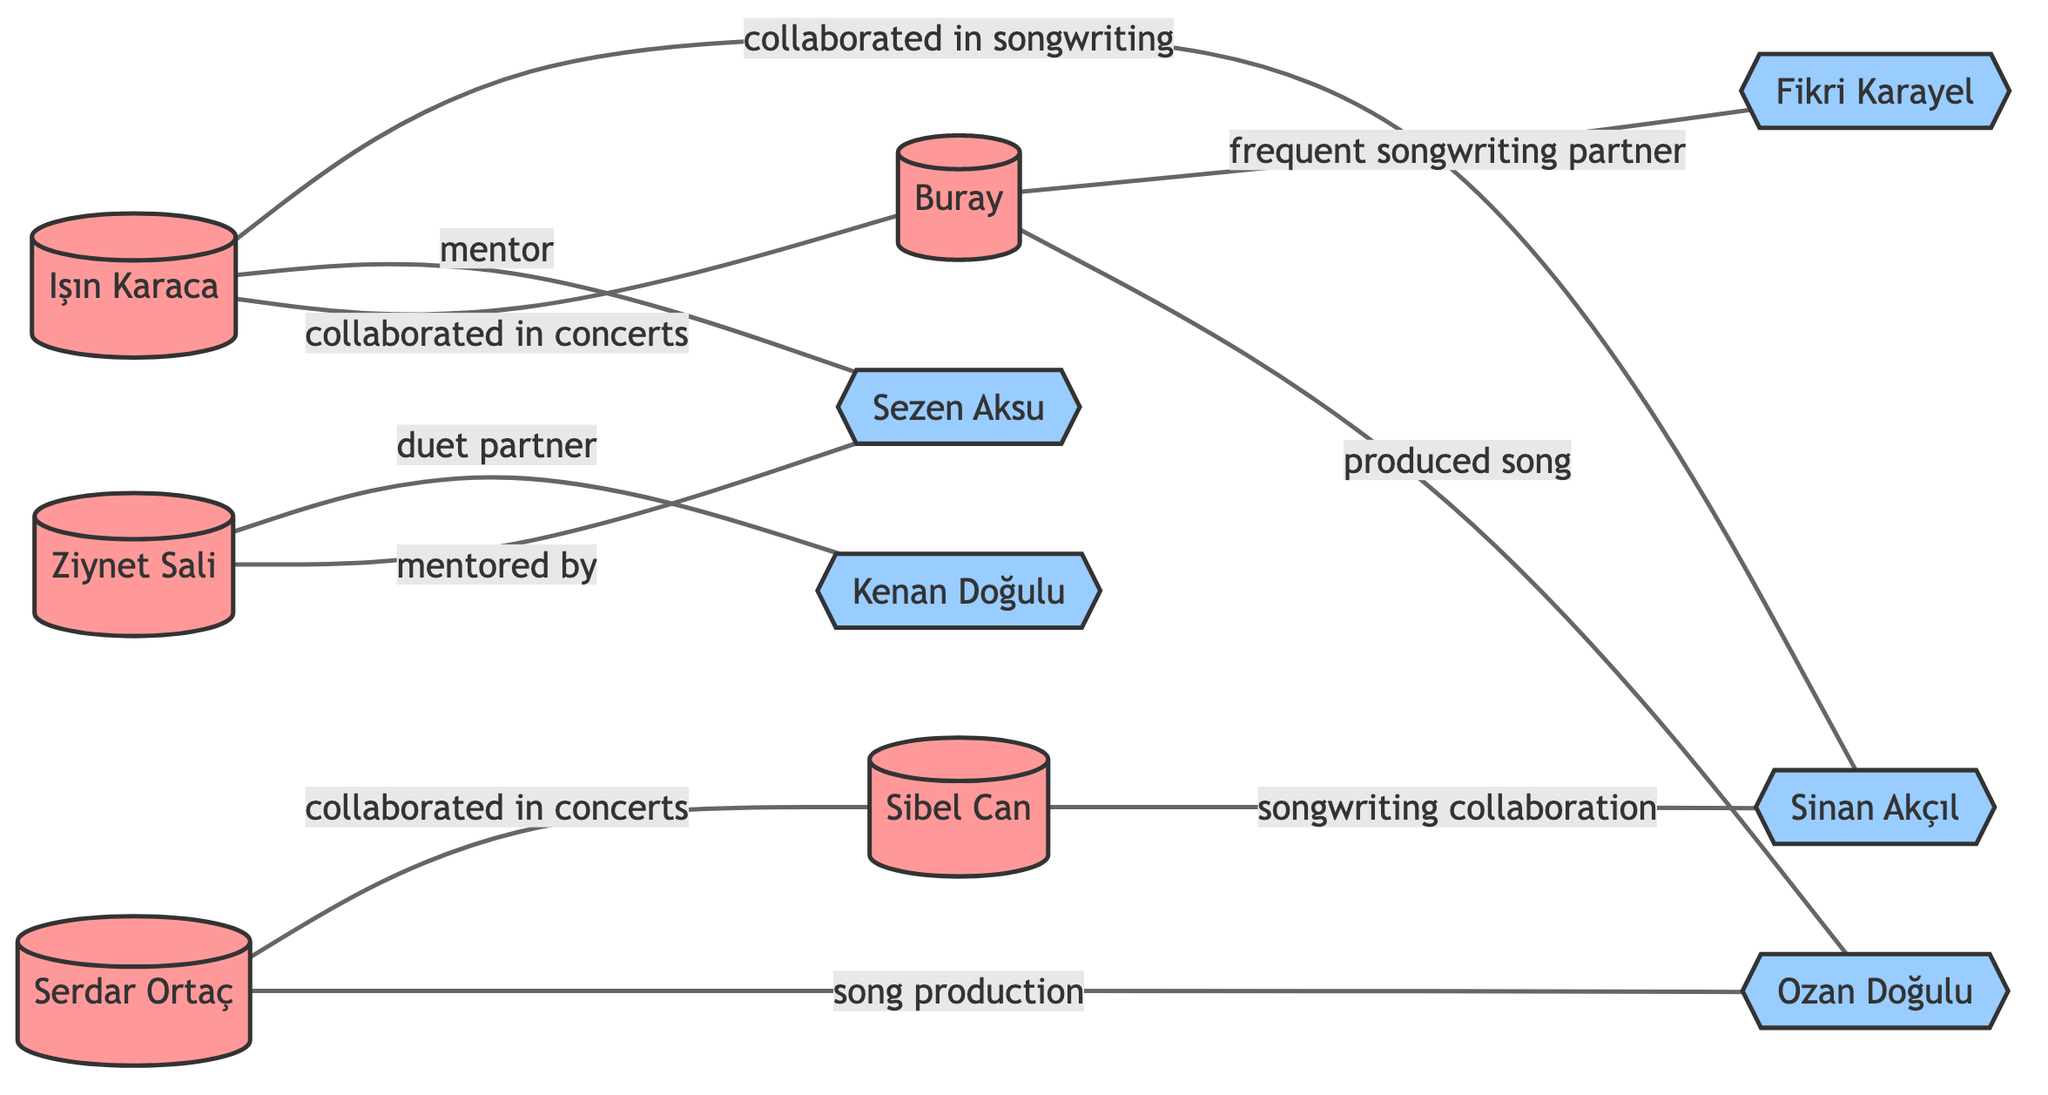What is the total number of artists in the diagram? The diagram lists five distinct nodes categorized as artists: Işın Karaca, Buray, Ziynet Sali, Serdar Ortaç, and Sibel Can. Therefore, counting these nodes gives a total of 5 artists.
Answer: 5 Who collaborated with Işın Karaca in songwriting? In the diagram, Işın Karaca is connected to Sinan Akçıl with the label "collaborated in songwriting," indicating that Sinan Akçıl collaborated with Işın Karaca in that capacity.
Answer: Sinan Akçıl Which artist is mentored by Sezen Aksu? The diagram shows an edge from Ziynet Sali to Sezen Aksu with the label "mentored by," confirming that Ziynet Sali is the artist mentored by Sezen Aksu.
Answer: Ziynet Sali How many total collaborations are listed in the diagram? By counting the edges connecting the nodes, the total number of collaborations is 9, as there are 9 labeled relationships indicating various forms of collaboration between the nodes.
Answer: 9 Which artists collaborated in concerts? Both Işın Karaca and Serdar Ortaç collaborated in concerts with the other artists as indicated by edges connecting them to Buray and Sibel Can respectively. Therefore, the answer includes Işın Karaca and Serdar Ortaç.
Answer: Işın Karaca, Serdar Ortaç What type of relationship exists between Buray and Ozan Doğulu? Based on the diagram, Buray has a relationship with Ozan Doğulu indicated by the edge labeled "produced song," which explicitly describes the nature of their collaboration.
Answer: produced song Who has the highest number of mentorship connections in the diagram? Examining the edges, Sezen Aksu is connected to two artists (Işın Karaca and Ziynet Sali), where both connections are labeled as mentorship. Therefore, she holds the highest number of mentorship connections.
Answer: Sezen Aksu How many collaborators are mentioned in the diagram? The diagram identifies five distinct collaborators: Sinan Akçıl, Kenan Doğulu, Sezen Aksu, Ozan Doğulu, and Fikri Karayel. Counting all the listed collaborator nodes gives the total.
Answer: 5 Which artist is a duet partner of Ziynet Sali? The diagram shows a direct connection from Ziynet Sali to Kenan Doğulu labeled "duet partner," confirming that Kenan Doğulu is the duet partner of Ziynet Sali.
Answer: Kenan Doğulu 